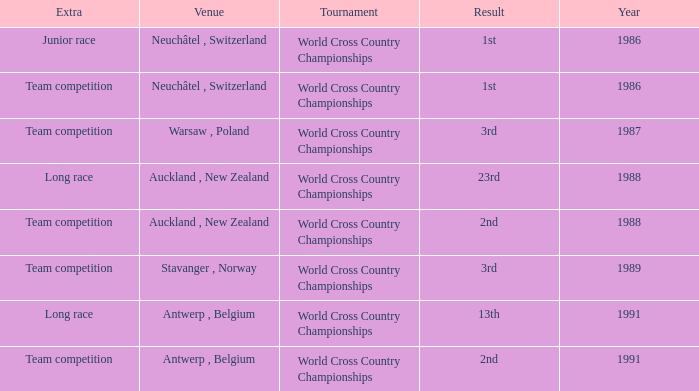Which venue had an extra of Junior Race? Neuchâtel , Switzerland. 